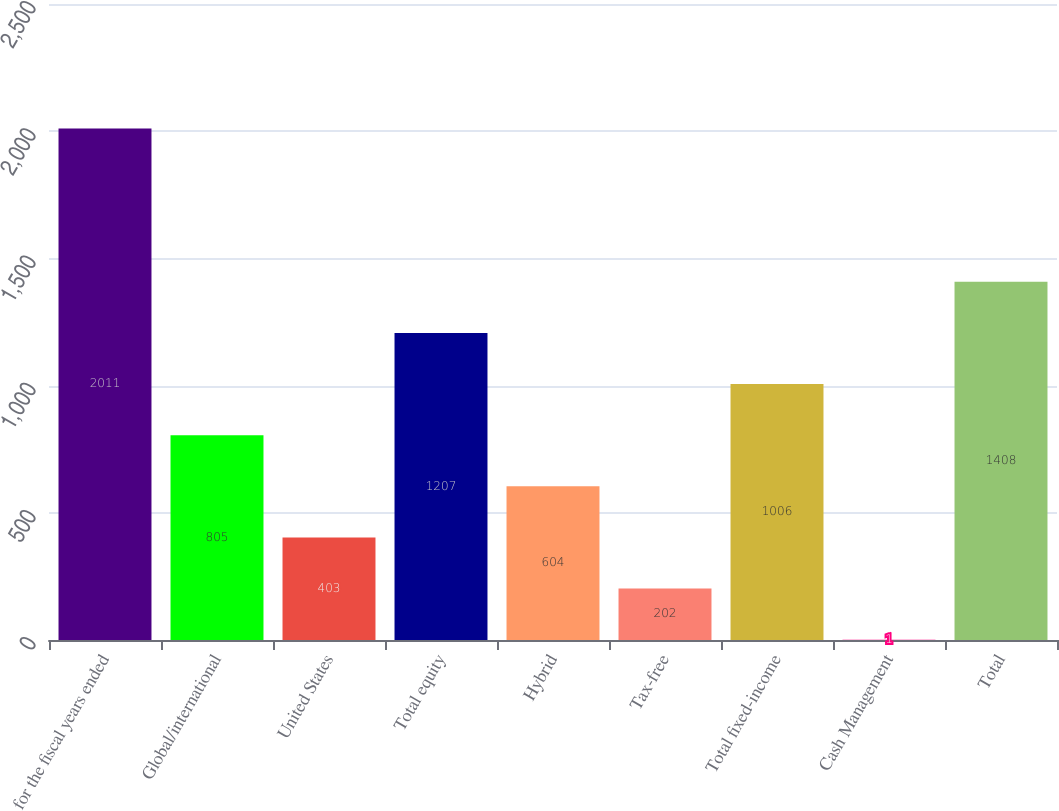<chart> <loc_0><loc_0><loc_500><loc_500><bar_chart><fcel>for the fiscal years ended<fcel>Global/international<fcel>United States<fcel>Total equity<fcel>Hybrid<fcel>Tax-free<fcel>Total fixed-income<fcel>Cash Management<fcel>Total<nl><fcel>2011<fcel>805<fcel>403<fcel>1207<fcel>604<fcel>202<fcel>1006<fcel>1<fcel>1408<nl></chart> 